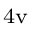<formula> <loc_0><loc_0><loc_500><loc_500>_ { 4 } v</formula> 